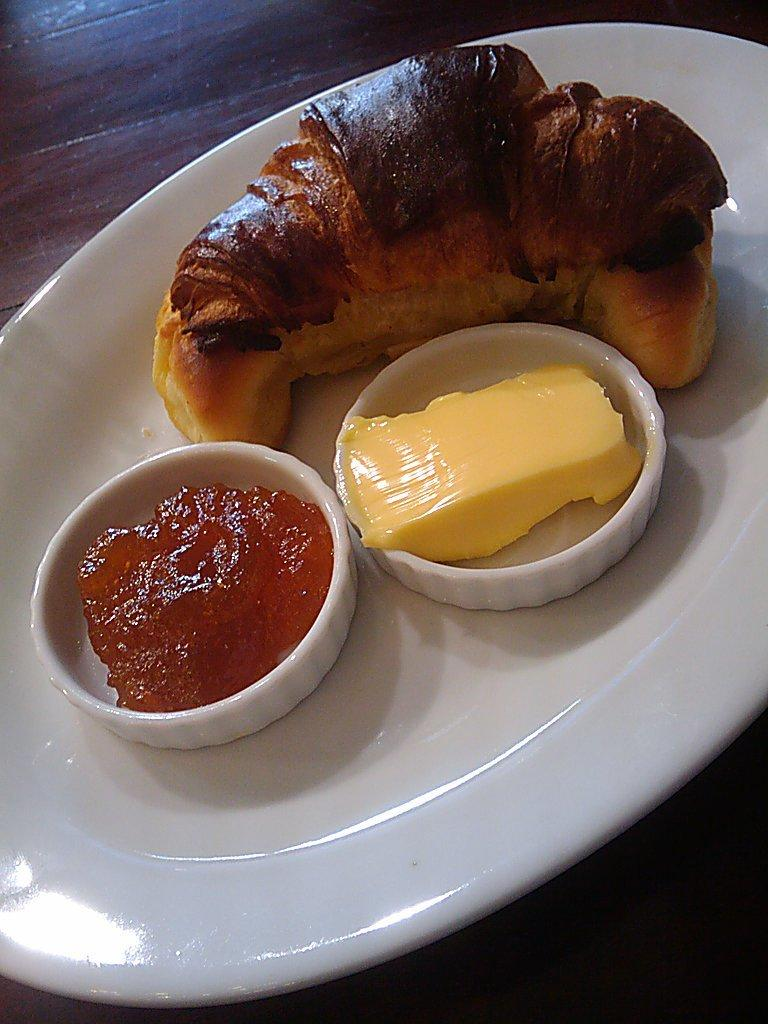What is on the plate that is visible in the image? There is a plate with food items in the image. How many bowls are on the plate? There are two bowls on the plate in the image. What is in the bowls on the plate? The bowls also contain food items. Where are the plate and bowls located in the image? The plate and bowls are on a table. What type of copper trade is depicted in the image? There is no copper trade or any reference to copper in the image; it features a plate with food items and bowls. 